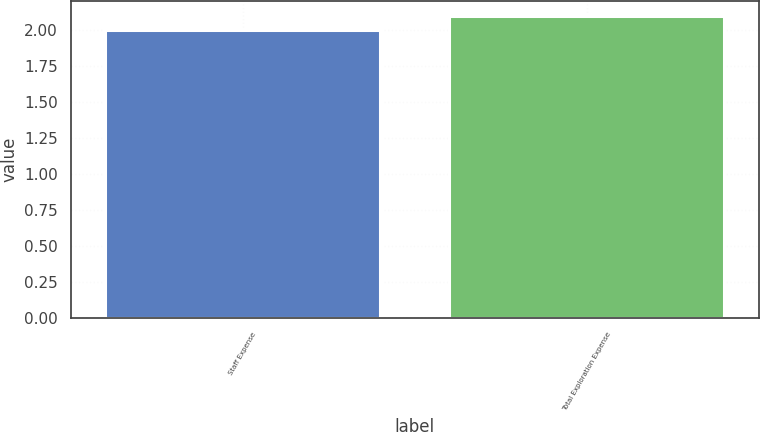<chart> <loc_0><loc_0><loc_500><loc_500><bar_chart><fcel>Staff Expense<fcel>Total Exploration Expense<nl><fcel>2<fcel>2.1<nl></chart> 